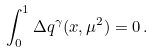<formula> <loc_0><loc_0><loc_500><loc_500>\int _ { 0 } ^ { 1 } \Delta q ^ { \gamma } ( x , \mu ^ { 2 } ) = 0 \, .</formula> 